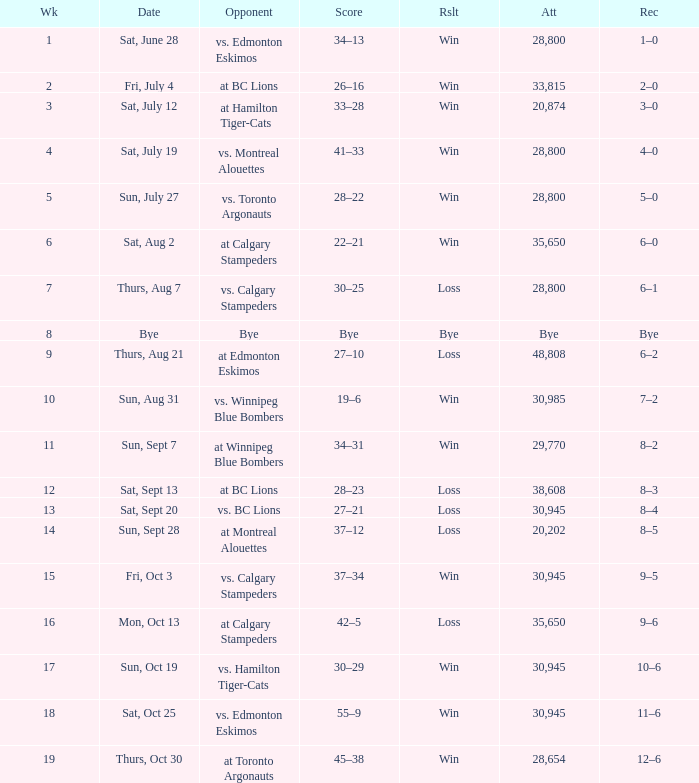What was the date of the game with an attendance of 20,874 fans? Sat, July 12. 